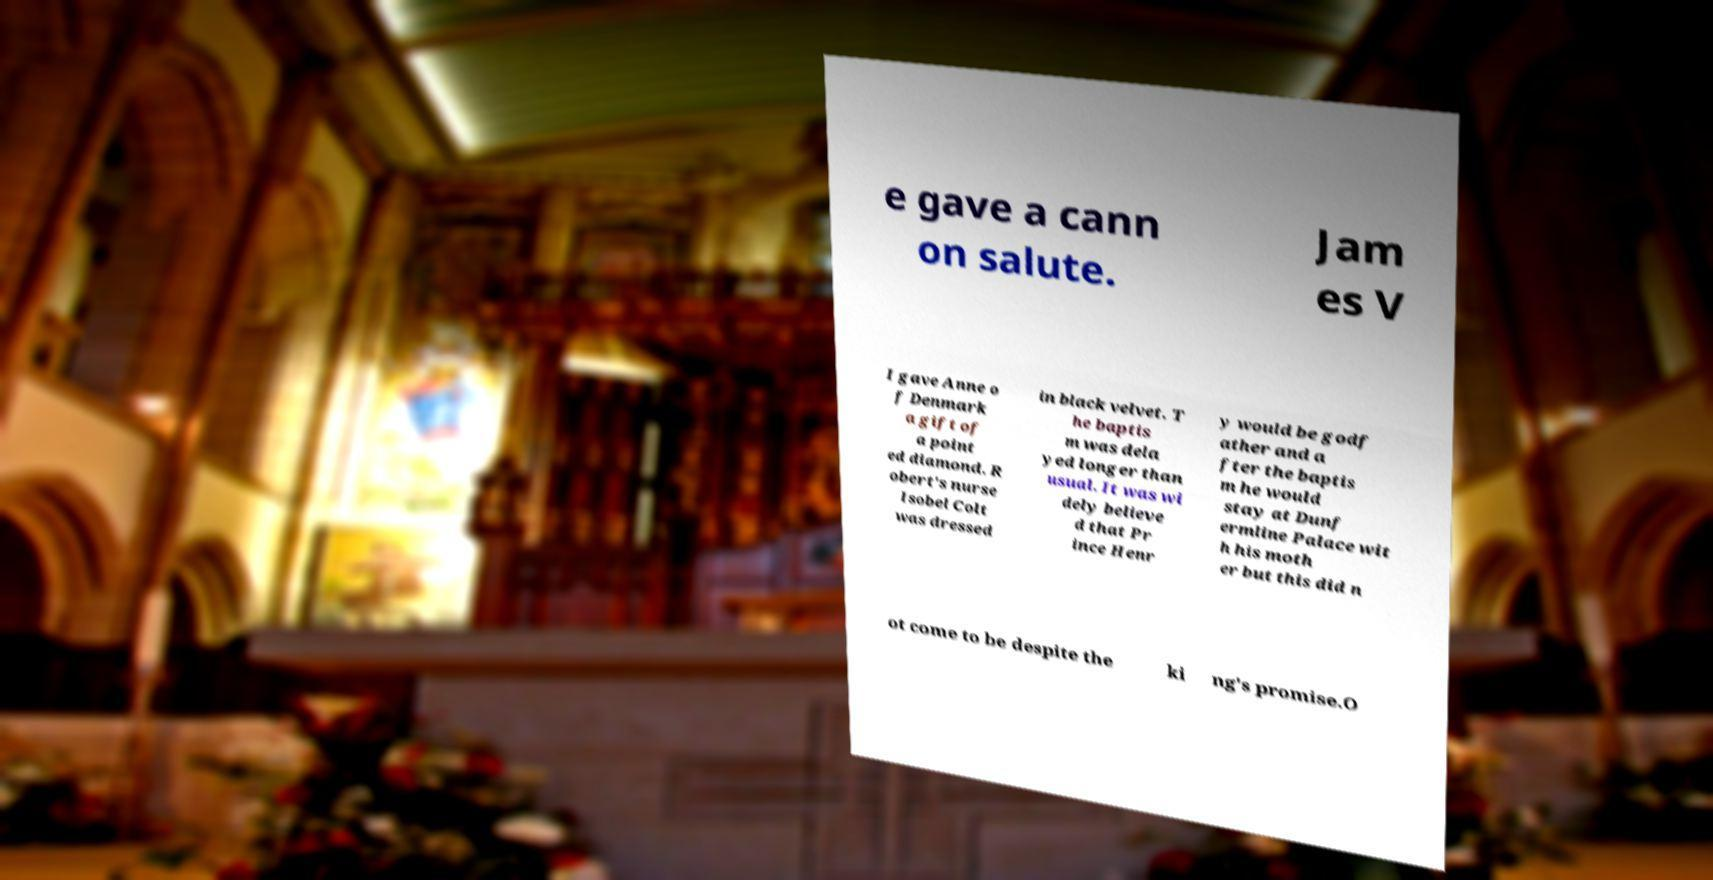Please read and relay the text visible in this image. What does it say? e gave a cann on salute. Jam es V I gave Anne o f Denmark a gift of a point ed diamond. R obert's nurse Isobel Colt was dressed in black velvet. T he baptis m was dela yed longer than usual. It was wi dely believe d that Pr ince Henr y would be godf ather and a fter the baptis m he would stay at Dunf ermline Palace wit h his moth er but this did n ot come to be despite the ki ng's promise.O 